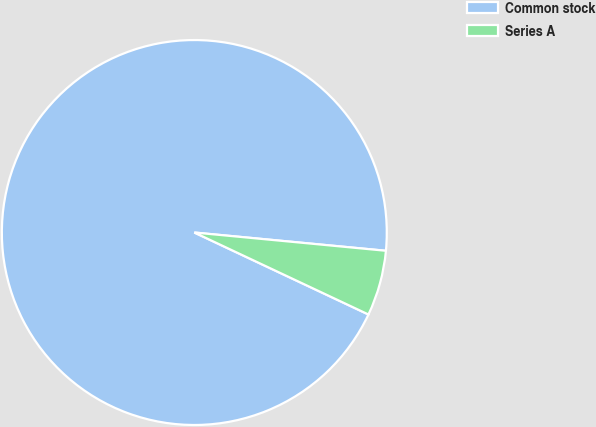<chart> <loc_0><loc_0><loc_500><loc_500><pie_chart><fcel>Common stock<fcel>Series A<nl><fcel>94.51%<fcel>5.49%<nl></chart> 